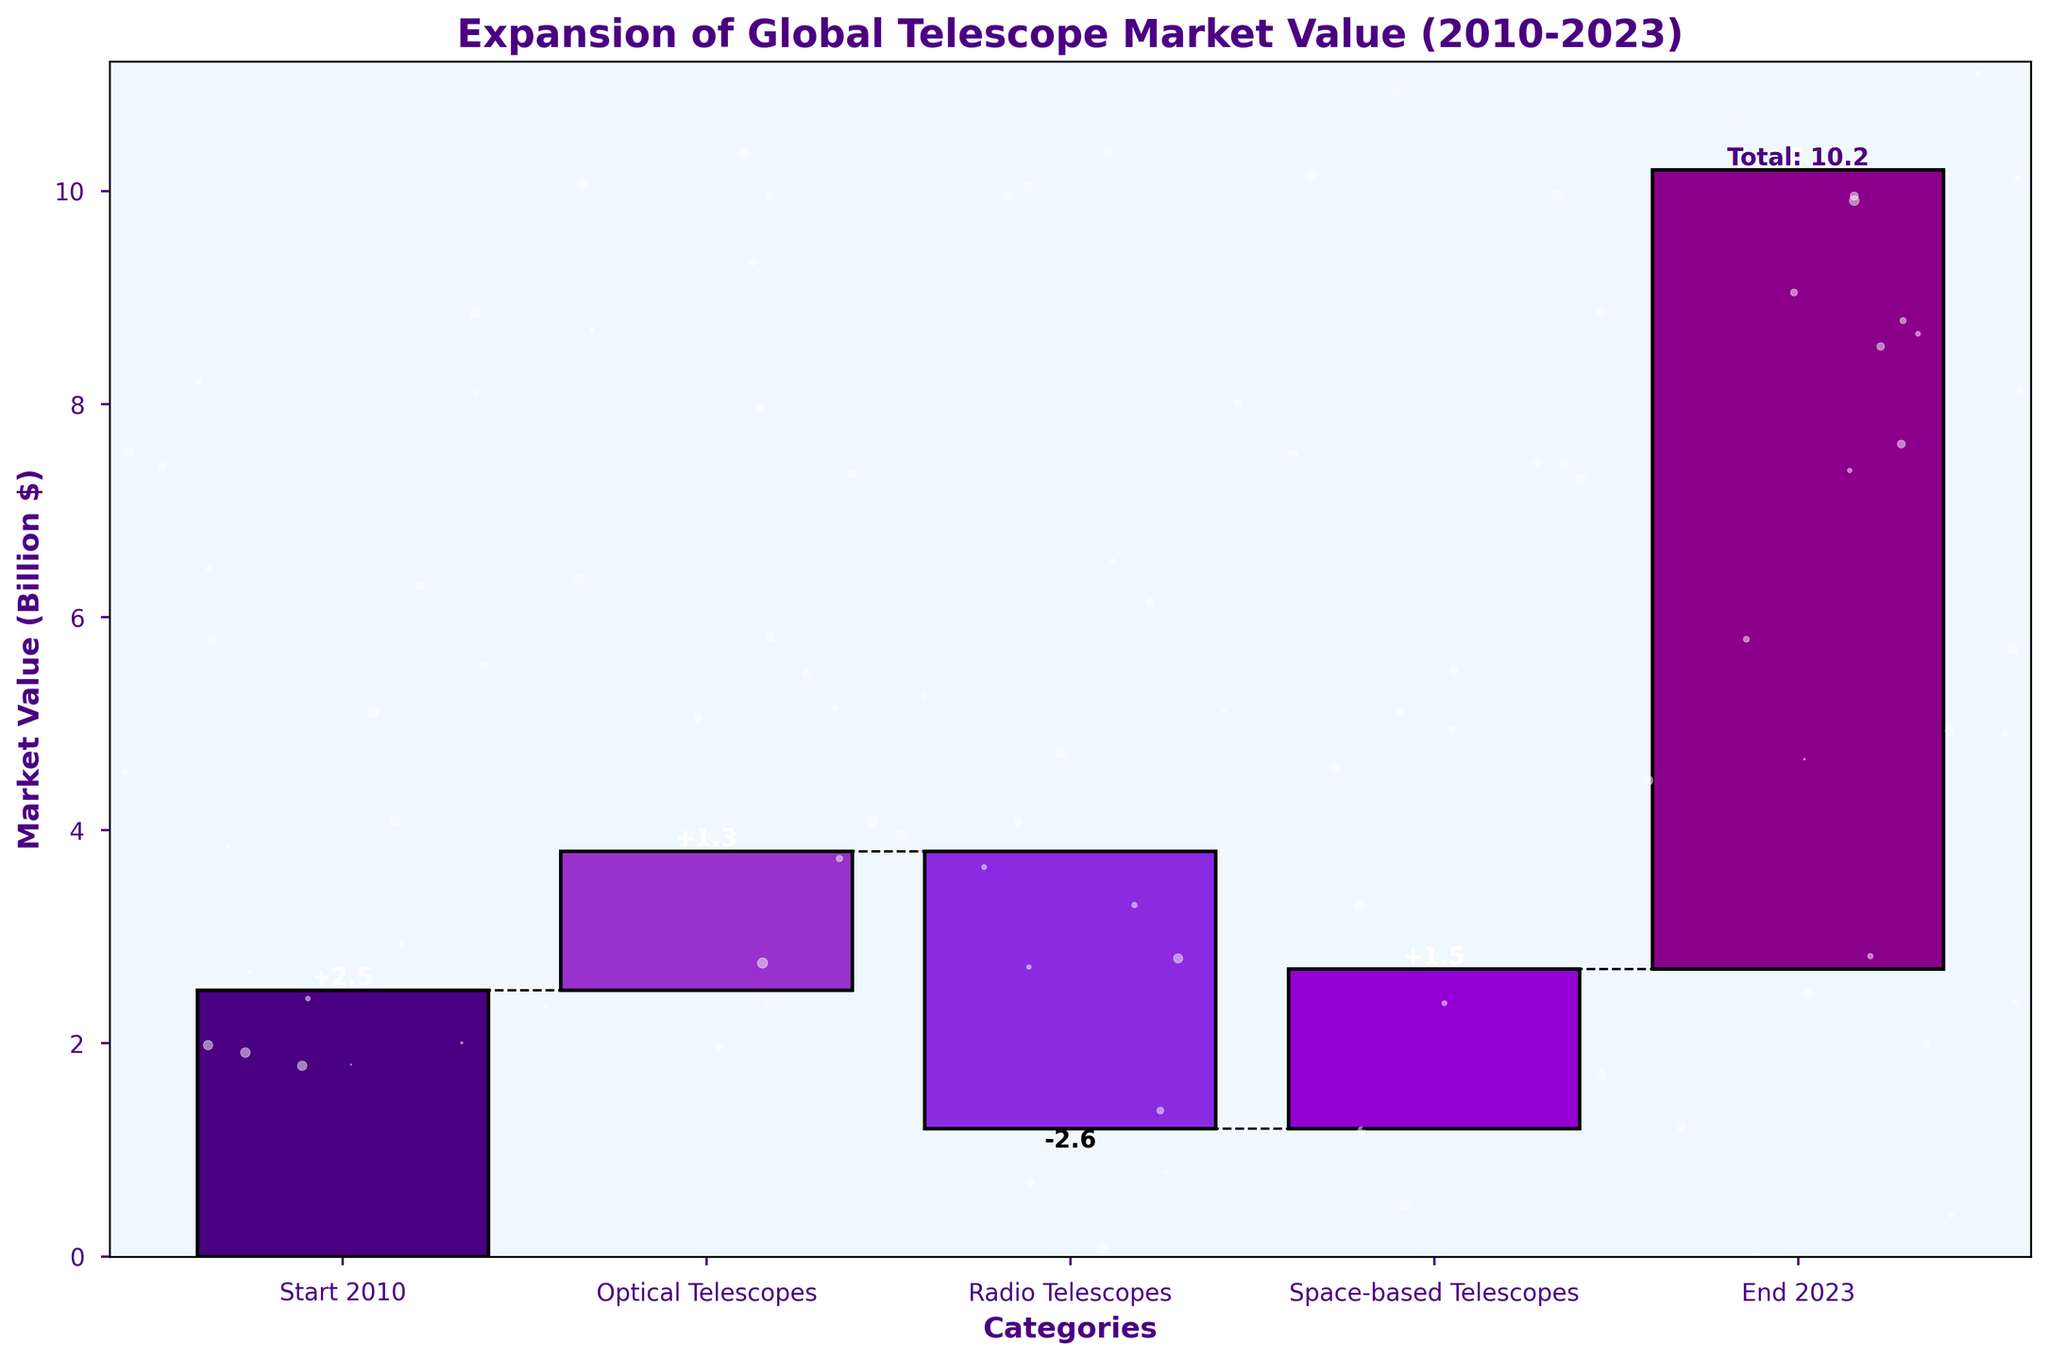what is the title of the chart? The title of the chart is displayed at the top and reads "Expansion of Global Telescope Market Value (2010-2023)"
Answer: Expansion of Global Telescope Market Value (2010-2023) How many categories are displayed in the chart? By counting the labeled bars on the x-axis, we can see a total of 5 categories.
Answer: 5 What is the final market value in 2023? The final market value in 2023 is shown at the end of the waterfall chart in the category "End 2023". The value is 10.2 billion.
Answer: 10.2 billion How much did optical telescopes contribute to the market value increase? The contribution of optical telescopes is represented by the height of the second bar in the chart. The value given for Optical Telescopes is 3.8 billion.
Answer: 3.8 billion How much did radio telescopes contribute to the market value increase? The contribution of radio telescopes is represented by the height of the third bar. The value given for Radio Telescopes is 1.2 billion.
Answer: 1.2 billion What was the market value increase due to space-based telescopes? The contribution of space-based telescopes is represented by the fourth bar. The value given for Space-based Telescopes is 2.7 billion.
Answer: 2.7 billion What was the starting market value in 2010? The starting market value in 2010 is represented by the first bar labeled “Start 2010.” The value is 2.5 billion.
Answer: 2.5 billion What is the overall increase in market value from 2010 to 2023? The overall increase is the difference between the final value in 2023 and the starting value in 2010. The calculation is 10.2 billion (End 2023) - 2.5 billion (Start 2010) = 7.7 billion
Answer: 7.7 billion Which type of telescope contributed the most to the market value increase? Comparing the contributions, Optical Telescopes (3.8 billion) have the highest contribution compared to Radio Telescopes (1.2 billion) and Space-based Telescopes (2.7 billion).
Answer: Optical Telescopes What was the total market value added by all telescopes from 2010 to 2023? Adding up the contributions of Optical (3.8 billion), Radio (1.2 billion), and Space-based Telescopes (2.7 billion) gives the total added value: 3.8 + 1.2 + 2.7 = 7.7 billion.
Answer: 7.7 billion 